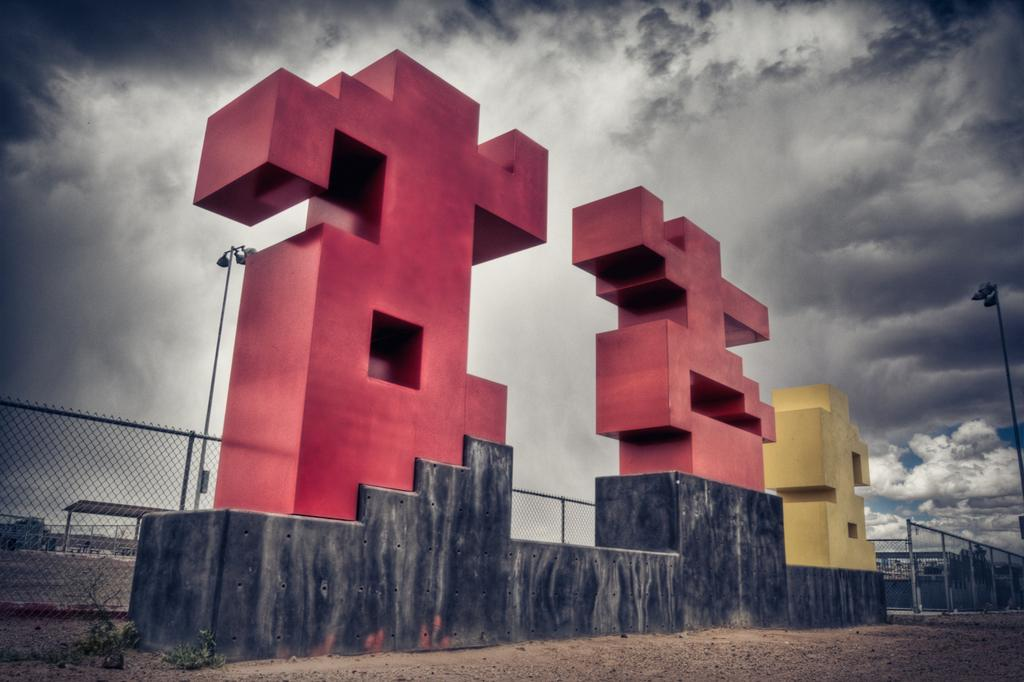What type of structure can be seen in the image? There is a small wall in the image. What else is present in the image besides the wall? There is fencing in the image. What part of the natural environment is visible in the image? The sky is visible in the image. How would you describe the weather based on the sky in the image? The sky is cloudy in the image. How many boats can be seen in the image? There are no boats present in the image. What type of cows are grazing near the wall in the image? There are no cows present in the image. 